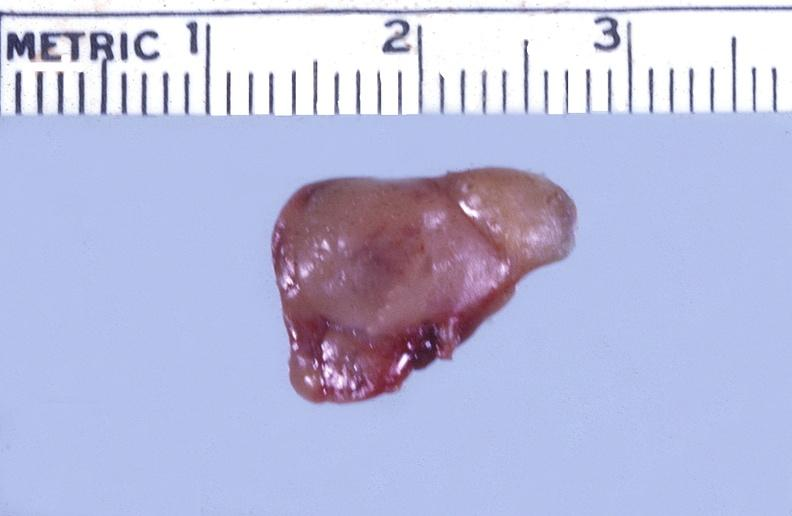where does this belong to?
Answer the question using a single word or phrase. Endocrine system 